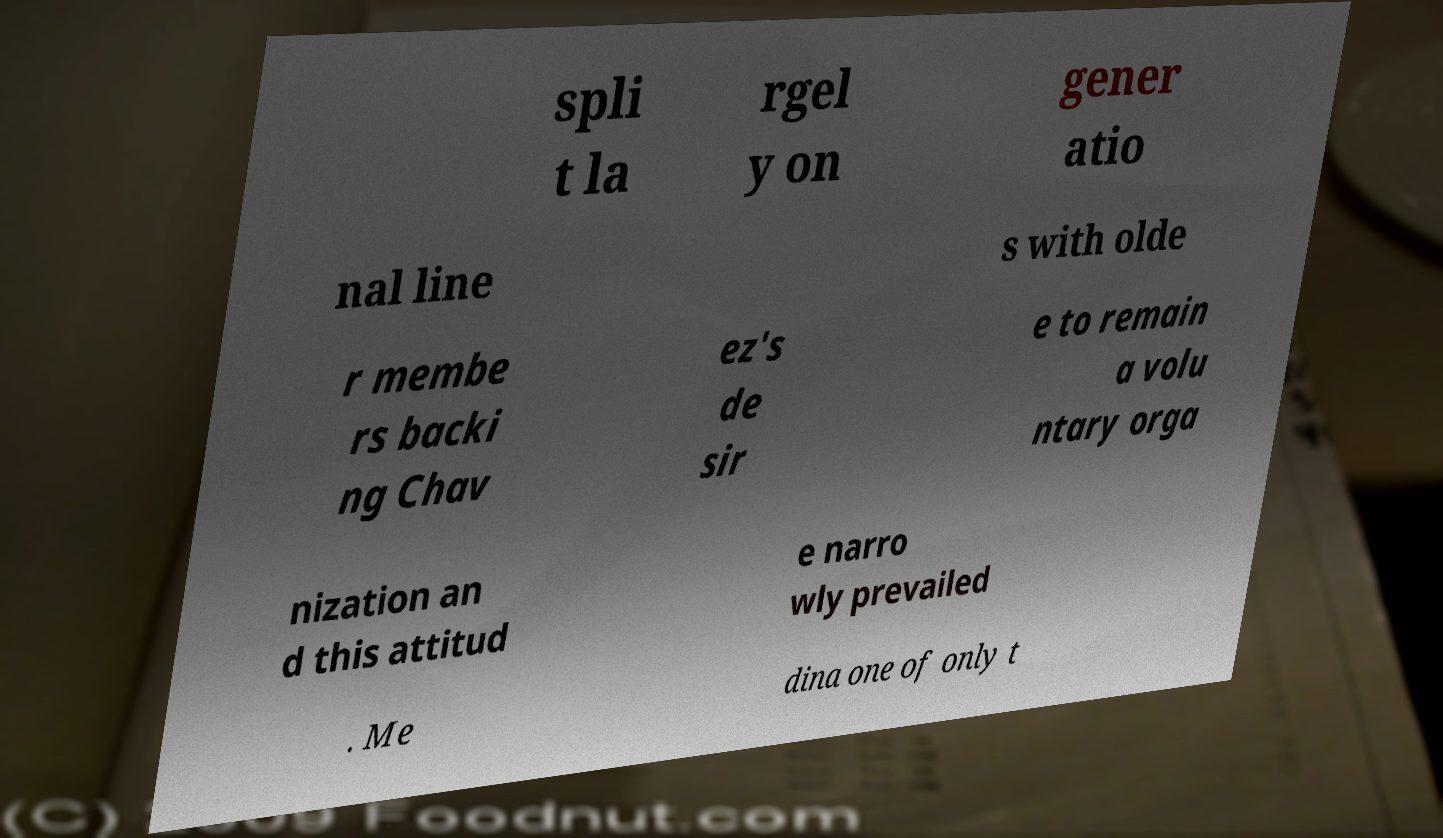Could you assist in decoding the text presented in this image and type it out clearly? spli t la rgel y on gener atio nal line s with olde r membe rs backi ng Chav ez's de sir e to remain a volu ntary orga nization an d this attitud e narro wly prevailed . Me dina one of only t 